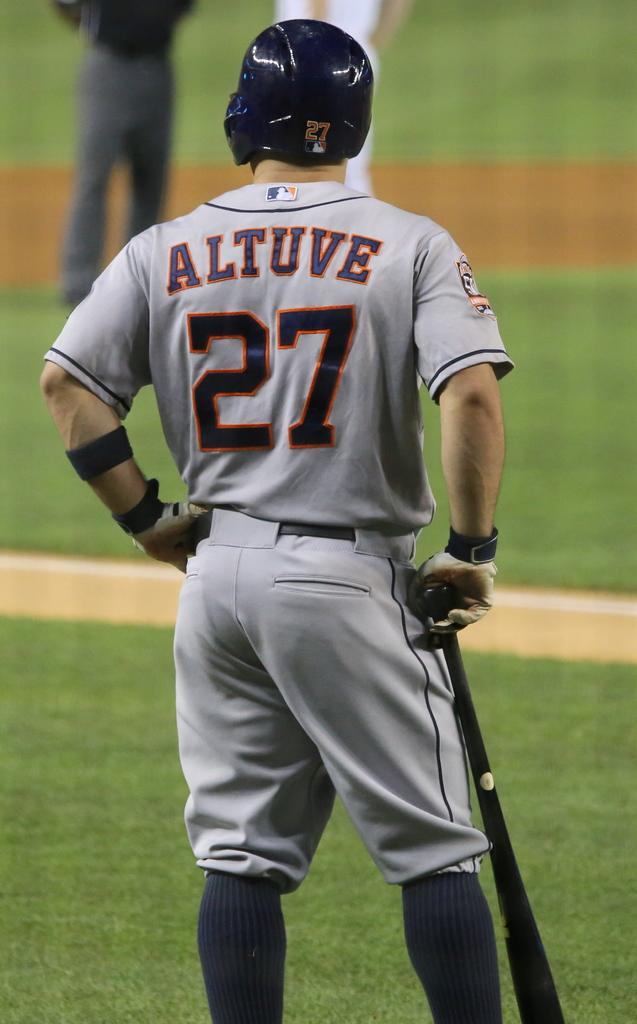Provide a one-sentence caption for the provided image. a baseball player in a grey 27 Altuve jersey waiting to bat. 